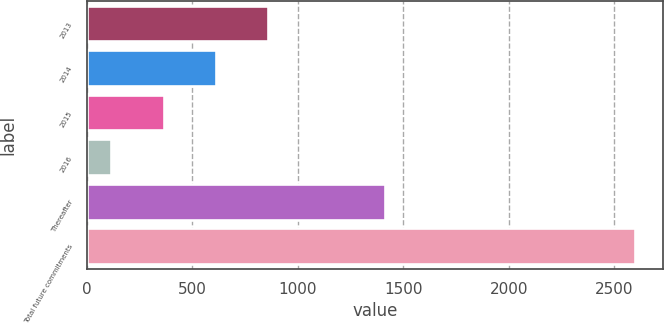Convert chart to OTSL. <chart><loc_0><loc_0><loc_500><loc_500><bar_chart><fcel>2013<fcel>2014<fcel>2015<fcel>2016<fcel>Thereafter<fcel>Total future commitments<nl><fcel>860.8<fcel>612.2<fcel>363.6<fcel>115<fcel>1412<fcel>2601<nl></chart> 